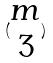Convert formula to latex. <formula><loc_0><loc_0><loc_500><loc_500>( \begin{matrix} m \\ 3 \end{matrix} )</formula> 